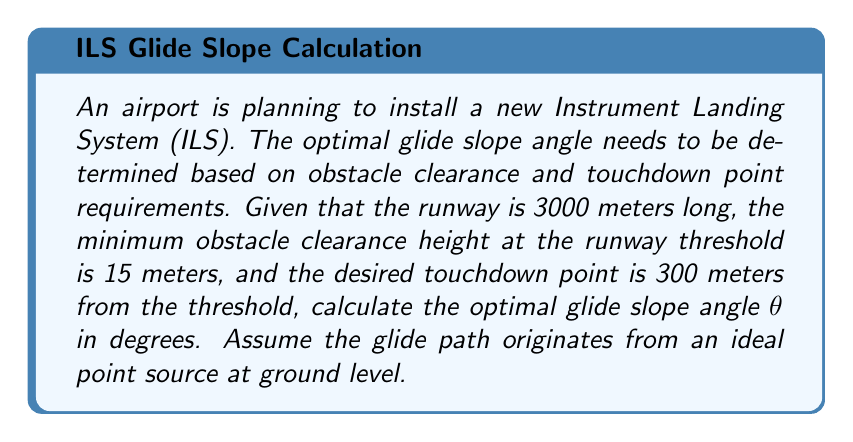Can you answer this question? To solve this problem, we need to use trigonometry and the given information to determine the optimal glide slope angle. Let's approach this step-by-step:

1. First, let's visualize the problem:

[asy]
import geometry;

size(300,200);

pair A = (0,0);
pair B = (250,0);
pair C = (25,15);
pair D = (250,15);

draw(A--B, arrow=Arrow(TeXHead));
draw(A--C, arrow=Arrow(TeXHead));
draw(C--D, dashed);

label("Runway Threshold", A, SW);
label("Touchdown Point", B, S);
label("15m", C, N);
label("300m", (125,0), S);
label("$\theta$", (10,5), NW);

draw(arc(A,10,0,atan(15/25)*180/pi), arrow=Arrow(TeXHead));
[/asy]

2. We need to find the angle $\theta$ that satisfies the given conditions.

3. The glide slope intersects the minimum obstacle clearance height (15 meters) at the runway threshold.

4. The distance from this point to the touchdown point is 300 meters.

5. We can form a right triangle with these measurements:
   - The adjacent side is 300 meters
   - The opposite side is 15 meters

6. Using the tangent function:

   $$\tan(\theta) = \frac{\text{opposite}}{\text{adjacent}} = \frac{15}{300} = \frac{1}{20} = 0.05$$

7. To find $\theta$, we take the inverse tangent (arctangent):

   $$\theta = \arctan(0.05)$$

8. Convert this to degrees:

   $$\theta = \arctan(0.05) \cdot \frac{180}{\pi}$$

9. Calculate the result:

   $$\theta \approx 2.86^\circ$$

This angle satisfies the requirements for obstacle clearance and touchdown point location while providing a comfortable descent rate for aircraft.
Answer: The optimal glide slope angle is approximately $2.86^\circ$. 